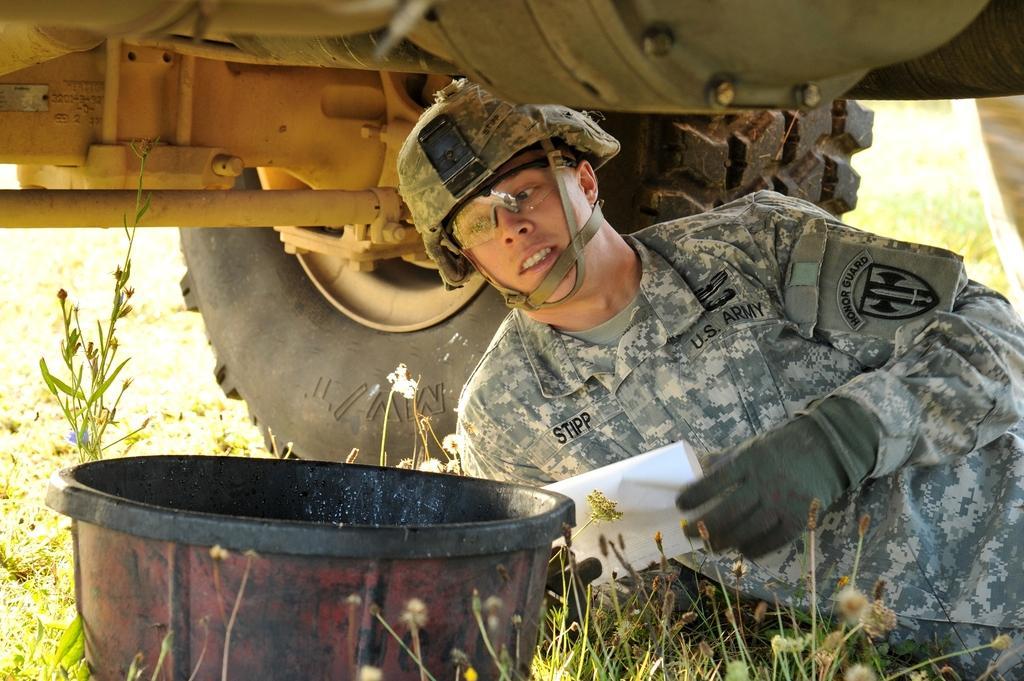Please provide a concise description of this image. In the foreground of the picture there are plants, grass, bucket and a soldier in uniform. The person is under a vehicle. The background is blurred. 